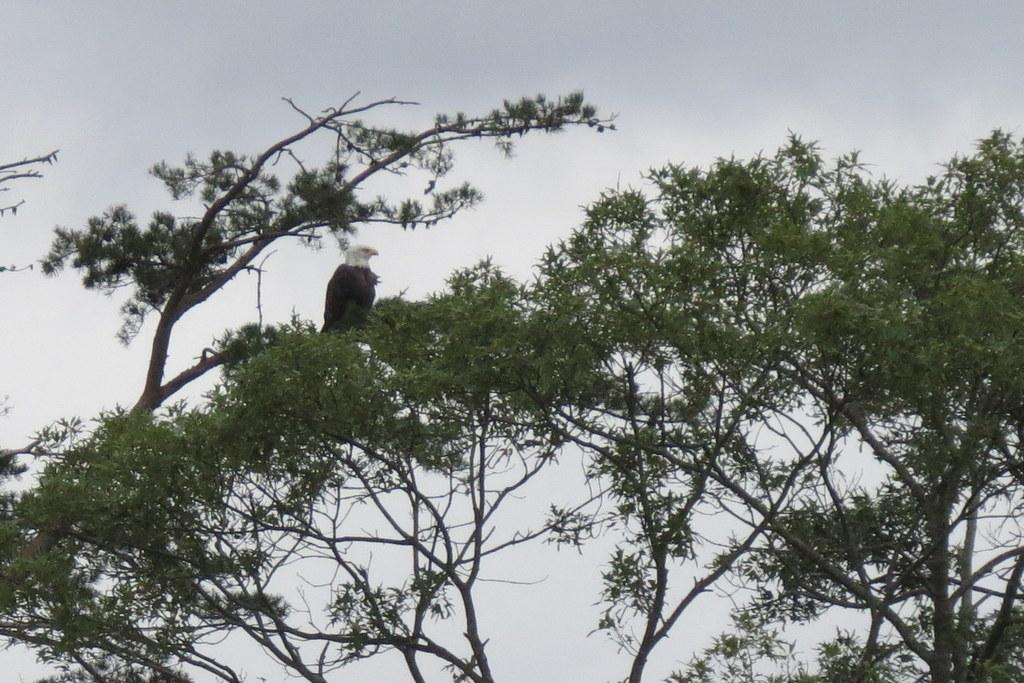What type of plant is featured in the image? There is a tree with branches in the image. What animal is sitting on the branches of the tree? A black and white eagle is sitting on the branches. What can be seen in the background of the image? The sky is visible in the image. How would you describe the weather based on the sky in the image? The sky is blue and clear, suggesting good weather. What caption is written on the notebook in the image? There is no notebook present in the image, so there is no caption to reference. 